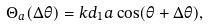<formula> <loc_0><loc_0><loc_500><loc_500>\Theta _ { a } ( \Delta \theta ) = k d _ { 1 } a \cos ( \theta + \Delta \theta ) ,</formula> 